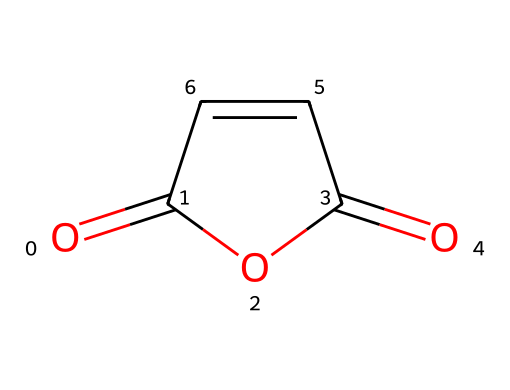What is the molecular formula of maleic anhydride? The structure of maleic anhydride, represented in SMILES as O=C1OC(=O)C=C1, indicates there are 4 carbon atoms (C), 2 oxygen atoms (O), and 4 hydrogen atoms (H). Therefore, the molecular formula derived from the atom counts is C4H2O3.
Answer: C4H2O3 How many carbon atoms are present in maleic anhydride? By analyzing the SMILES representation, there are 4 carbon atoms visible in the structural formula (C=C and the two carbonyl groups).
Answer: 4 What type of functional groups are present in maleic anhydride? The molecule contains carbonyl (C=O) groups as part of the anhydride structure and a double bond (C=C), indicating it is an unsaturated compound.
Answer: carbonyl and double bond What does the term "anhydride" imply about maleic anhydride's structure? The term "anhydride" indicates that the compound is derived from an acid by the removal of water, implying that it has two carbonyl (C=O) groups and a ring structure, which confirms the loss of water between carboxylic acid groups.
Answer: derived from an acid What type of reaction is maleic anhydride commonly used in for polymer production? Maleic anhydride is typically used in addition polymerization reactions, where it reacts with unsaturated compounds (such as styrene) to form unsaturated polyester resins through cross-linking.
Answer: addition polymerization 